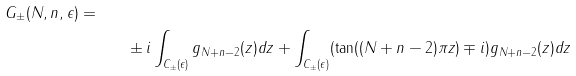Convert formula to latex. <formula><loc_0><loc_0><loc_500><loc_500>{ G _ { \pm } ( N , n , \epsilon ) = } \quad \\ & \pm i \int _ { C _ { \pm } ( \epsilon ) } g _ { N + n - 2 } ( z ) d z + \int _ { C _ { \pm } ( \epsilon ) } ( \tan ( ( N + n - 2 ) \pi z ) \mp i ) g _ { N + n - 2 } ( z ) d z</formula> 